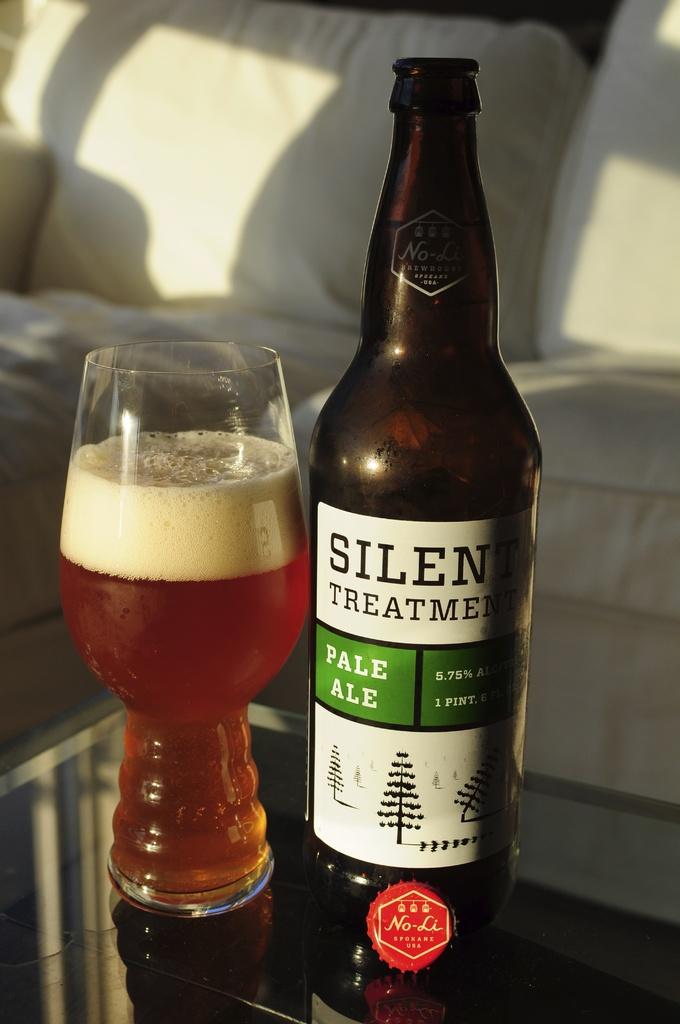What brand of ale is this?
Keep it short and to the point. Silent treatment. 